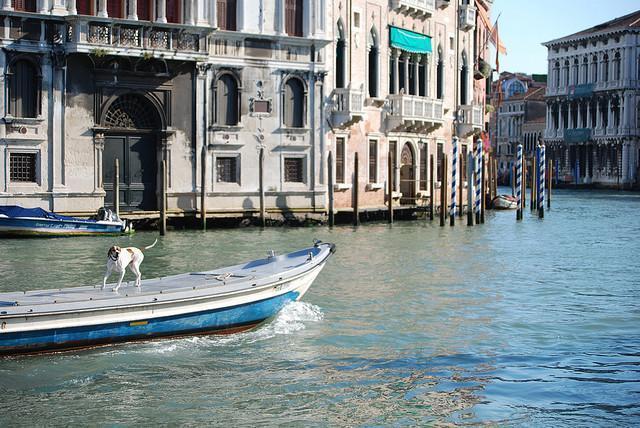What are these waterways equivalent in usage to in other cities and countries?
Pick the correct solution from the four options below to address the question.
Options: Streams, lakes, tarmacs, streets. Streets. 